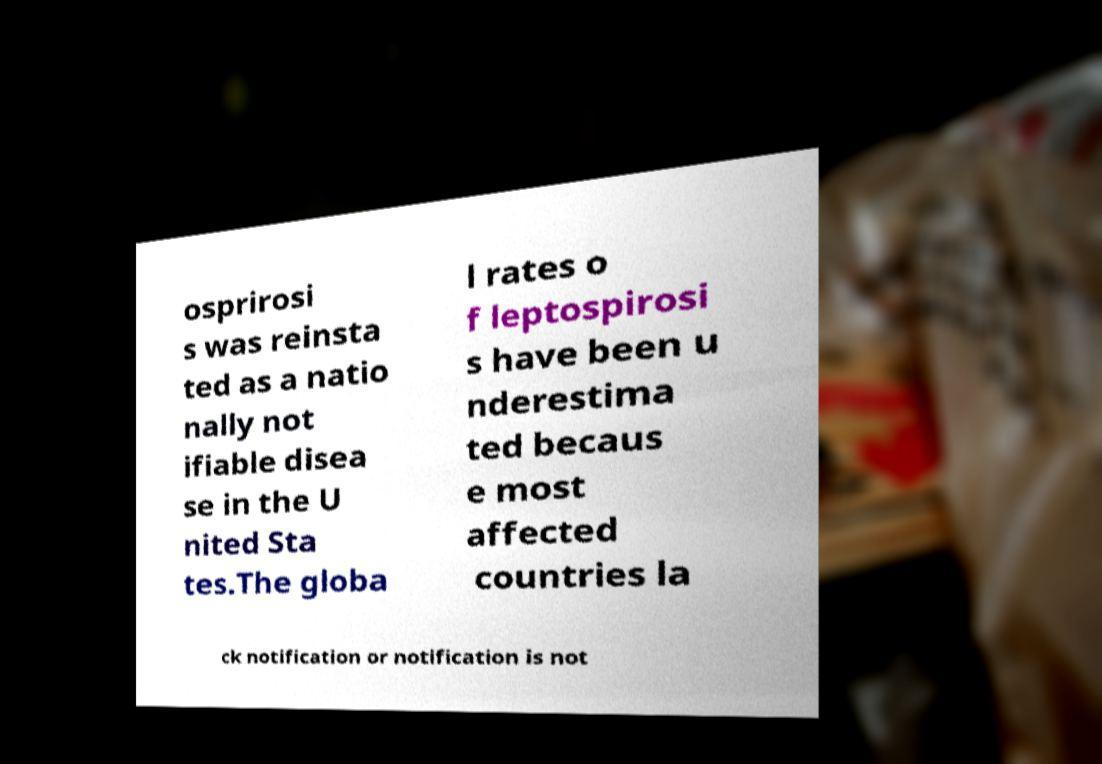What messages or text are displayed in this image? I need them in a readable, typed format. osprirosi s was reinsta ted as a natio nally not ifiable disea se in the U nited Sta tes.The globa l rates o f leptospirosi s have been u nderestima ted becaus e most affected countries la ck notification or notification is not 